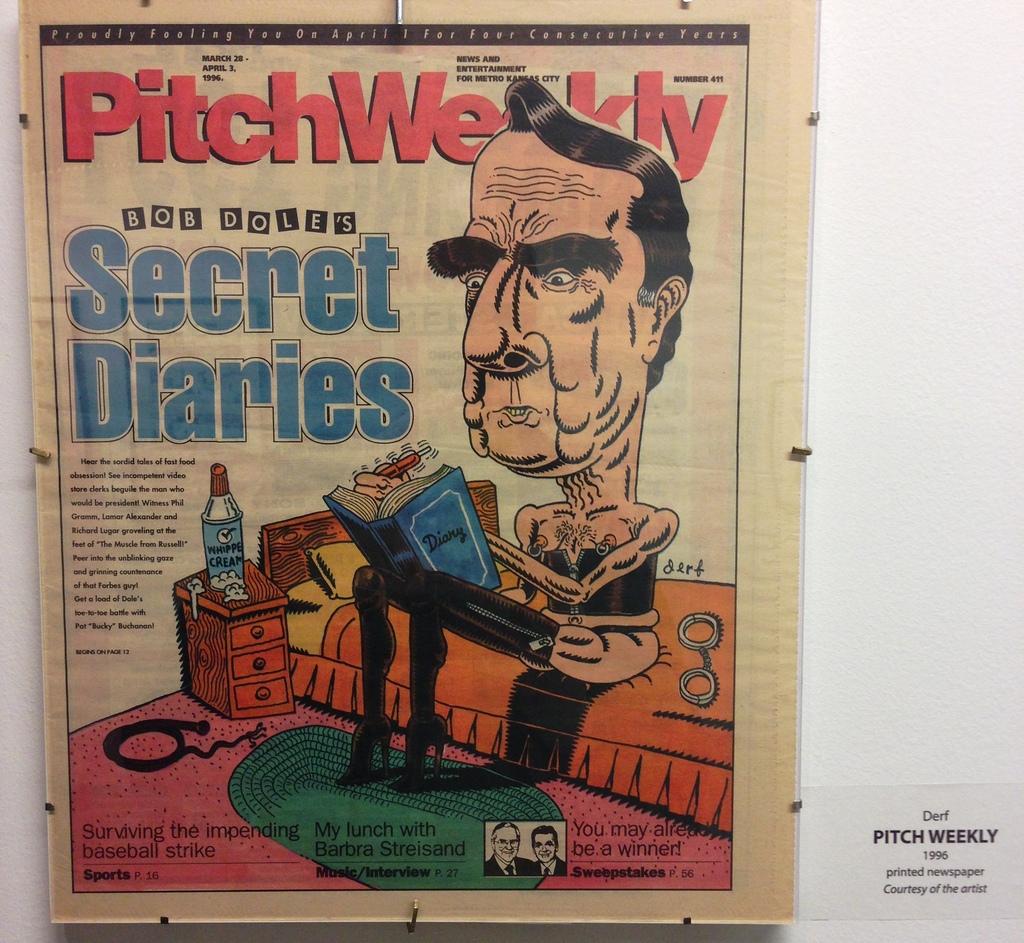Who has the secret diaries?
Make the answer very short. Bob dole. What is the magazine's name?
Your answer should be compact. Pitchweekly. 